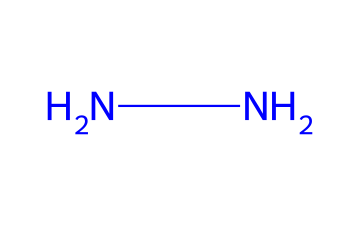how many nitrogen atoms are in hydrazine? Hydrazine is represented by the SMILES code NN, indicating two nitrogen atoms are directly connected to each other.
Answer: 2 what type of bonding exists between the nitrogen atoms in hydrazine? The two nitrogen atoms in hydrazine (NN) are connected by a single bond, which can be deduced from the SMILES representation where there's no indication of multiple bonds.
Answer: single bond what is the molecular formula of hydrazine? The two nitrogen atoms in hydrazine combine to form the molecular formula N2H4, as hydrazine also contains four hydrogen atoms needed to satisfy the nitrogen’s valence.
Answer: N2H4 what are the oxidation states of the nitrogen atoms in hydrazine? In hydrazine, both nitrogen atoms have an oxidation state of -2, which is derived from the bonding environment and the presence of hydrogen atoms that contribute +1 each.
Answer: -2 what is the primary use of hydrazine in space exploration? Hydrazine is primarily used as a propellant due to its high energy density and ability to produce thrust when it decomposes.
Answer: propellant why is hydrazine considered toxic? Hydrazine is considered toxic due to its reactivity and potential to form harmful by-products, as the nitrogen atoms in the molecule can contribute to the formation of harmful nitrogen oxides upon combustion.
Answer: toxic 